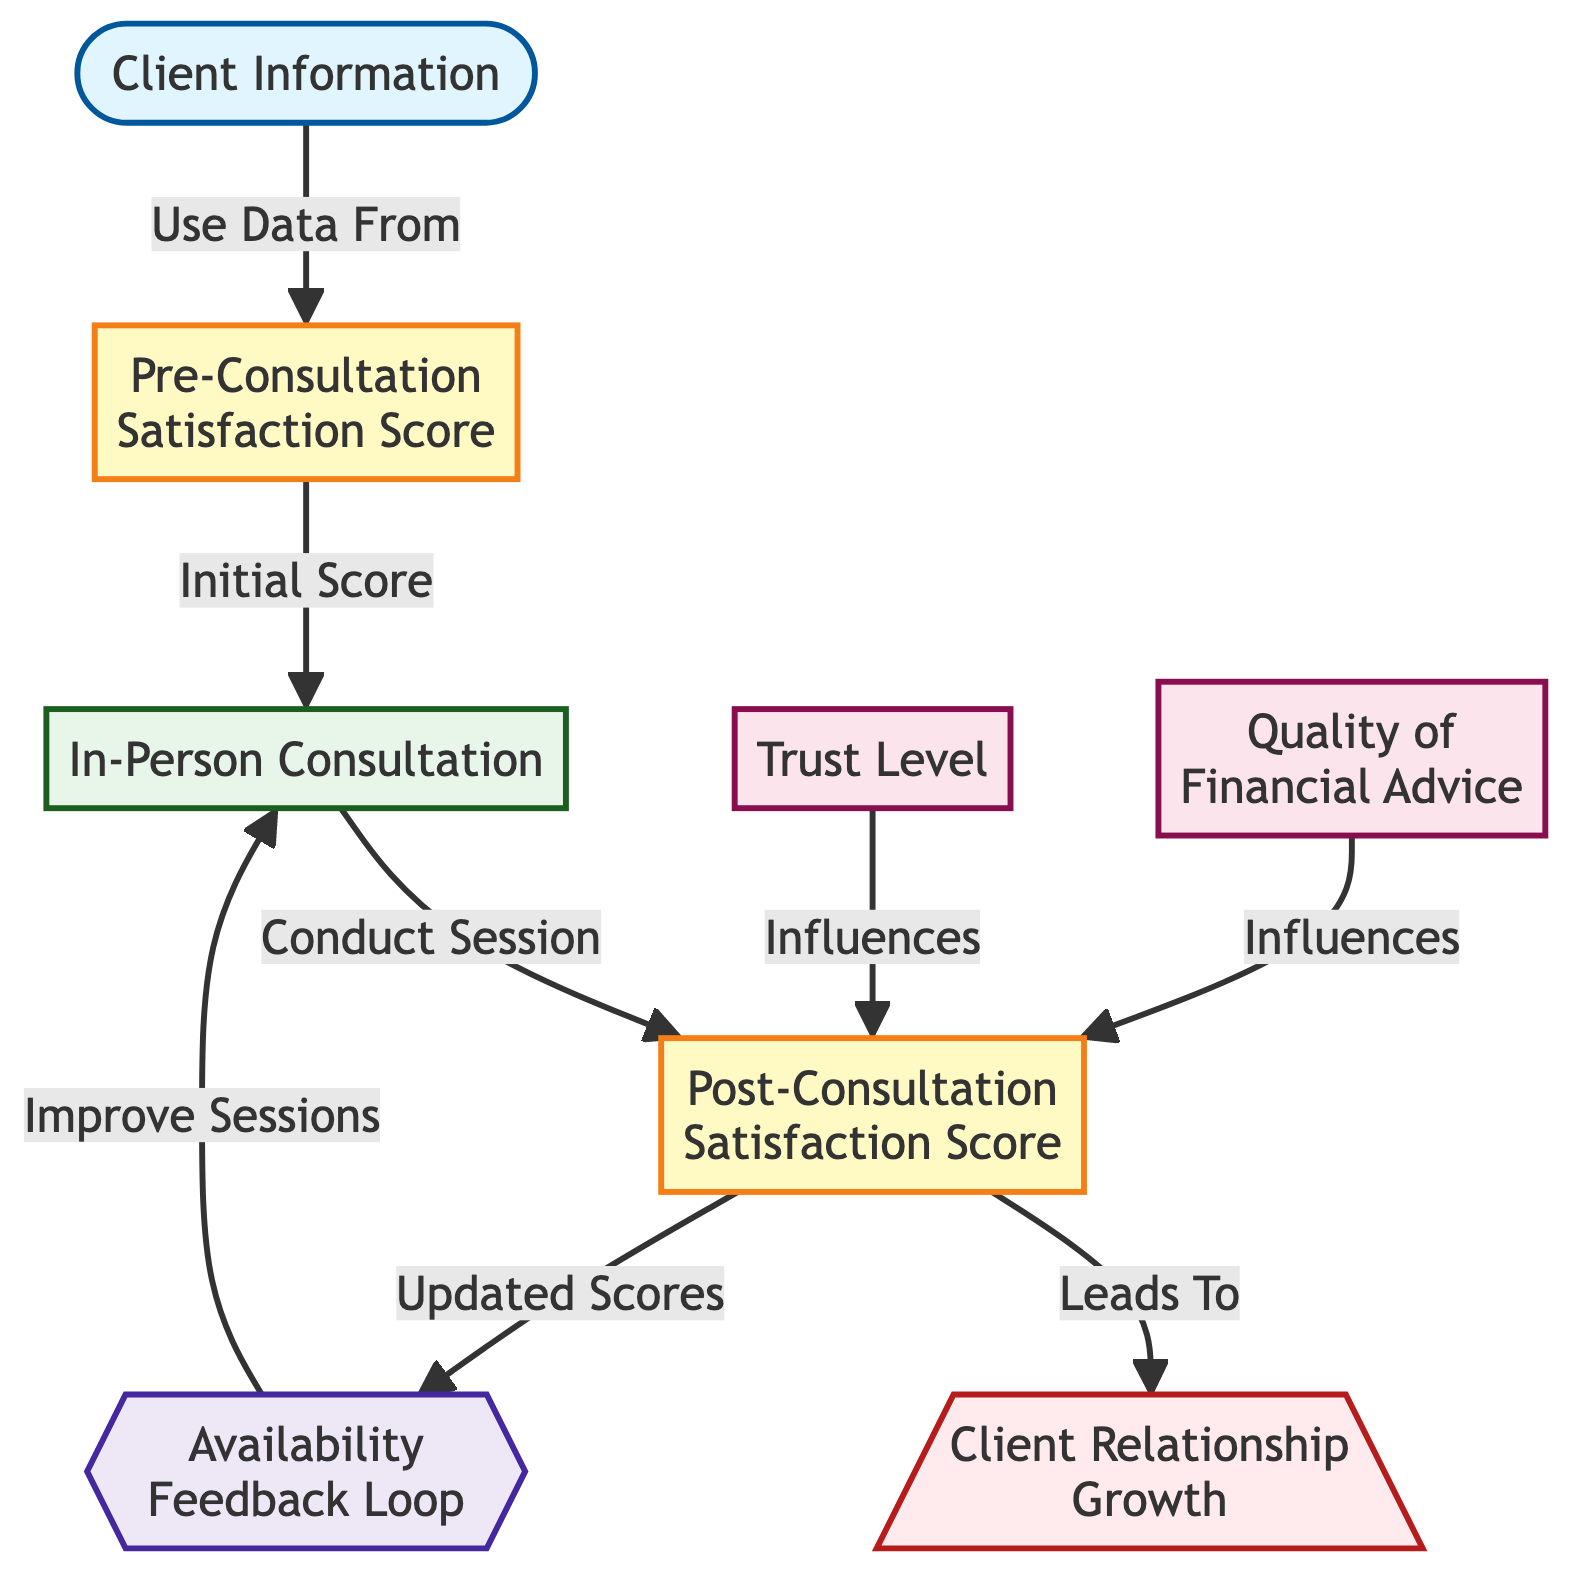What are the two main satisfaction scores displayed in the diagram? The diagram indicates two main satisfaction scores: "Pre-Consultation Satisfaction Score" and "Post-Consultation Satisfaction Score." These are explicitly labeled in the diagram as metric nodes.
Answer: Pre-Consultation Satisfaction Score, Post-Consultation Satisfaction Score How does the "Trust Level" influence the "Post-Consultation Satisfaction Score"? The diagram shows a direct arrow from "Trust Level" to "Post-Consultation Satisfaction Score," indicating that "Trust Level" has an influence on the satisfaction score after the consultation.
Answer: Influences What follows the "In-Person Consultation" process? After "In-Person Consultation," the next node is "Post-Consultation Satisfaction Score," which is where scores are recorded following the consultation process.
Answer: Post-Consultation Satisfaction Score Which feedback loop is present in the diagram? The diagram depicts an "Availability Feedback Loop," indicating that feedback related to availability helps improve future sessions of in-person consultation.
Answer: Availability Feedback Loop How does the "Post-Consultation Satisfaction Score" affect client relationship growth? The diagram shows an arrow leading from "Post-Consultation Satisfaction Score" to "Client Relationship Growth," indicating that higher satisfaction scores contribute positively to the growth of client relationships.
Answer: Leads To What is the role of "Quality of Financial Advice" in the diagram? "Quality of Financial Advice" is represented as a factor that directly influences "Post-Consultation Satisfaction Score," which suggests that better advice correlates with higher satisfaction.
Answer: Influences How many main nodes are present in the diagram that correspond to different satisfaction scores? The diagram lists two main nodes that correspond to satisfaction scores: Pre-Consultation Satisfaction Score and Post-Consultation Satisfaction Score. Therefore, there are two main nodes regarding satisfaction.
Answer: 2 What is the purpose of the "In-Person Consultation" node? The "In-Person Consultation" node represents the process through which client sessions are conducted, leading to a change in satisfaction scores both before and after the consultation.
Answer: Conduct Session What outcomes do the feedback loops aim to achieve in the context of the diagram? The feedback loops aim to improve the availability and overall quality of in-person consultations based on the scores gathered from client satisfaction evaluations.
Answer: Improve Sessions 